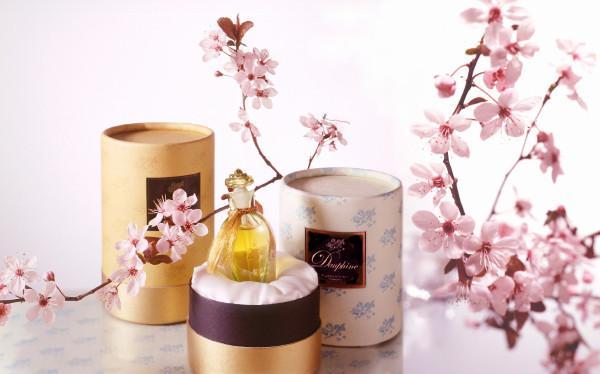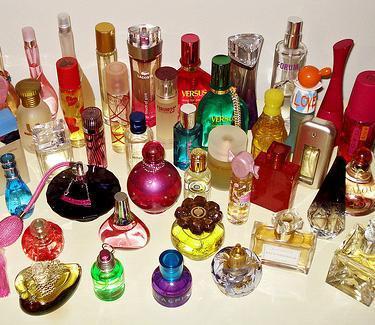The first image is the image on the left, the second image is the image on the right. For the images shown, is this caption "The image on the left boasts less than ten items." true? Answer yes or no. Yes. The first image is the image on the left, the second image is the image on the right. Evaluate the accuracy of this statement regarding the images: "The collection of fragrance bottles on the right includes a squat round black bottle with a pink tube and bulb attached.". Is it true? Answer yes or no. Yes. 